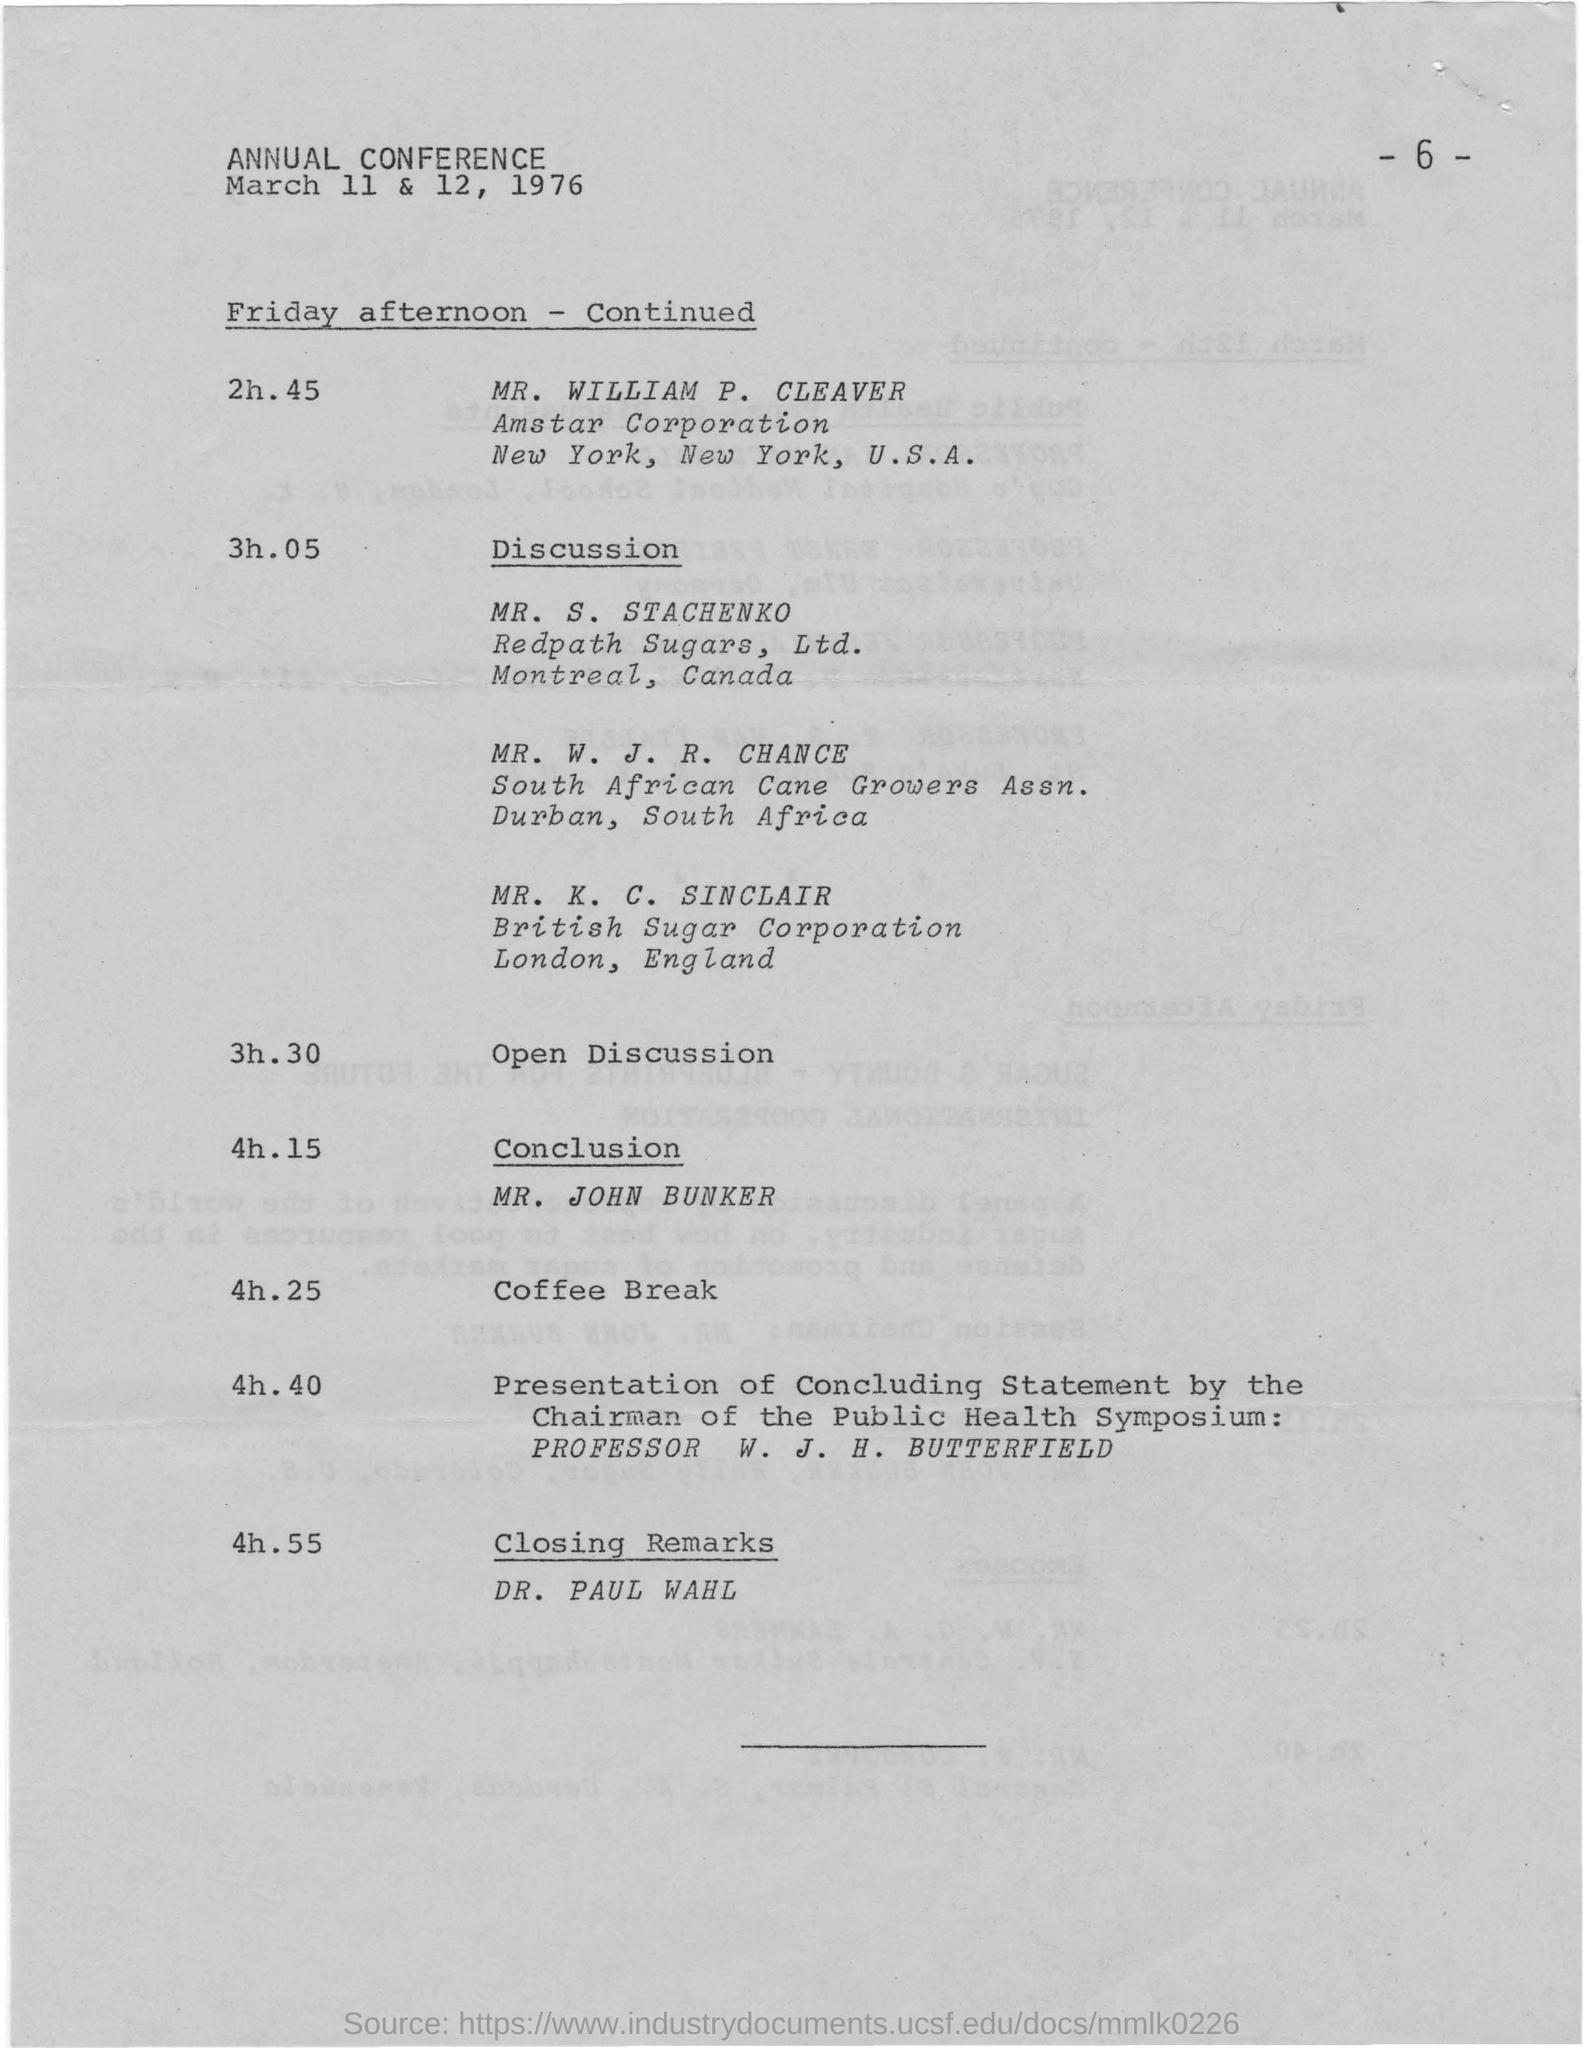Highlight a few significant elements in this photo. The annual conference is scheduled for March 11 and 12, 1976. The annual conference was concluded with closing remarks delivered by DR. PAUL WAHL. 